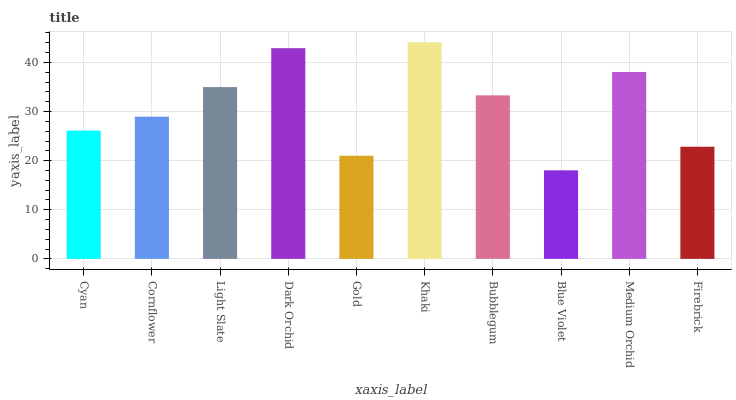Is Blue Violet the minimum?
Answer yes or no. Yes. Is Khaki the maximum?
Answer yes or no. Yes. Is Cornflower the minimum?
Answer yes or no. No. Is Cornflower the maximum?
Answer yes or no. No. Is Cornflower greater than Cyan?
Answer yes or no. Yes. Is Cyan less than Cornflower?
Answer yes or no. Yes. Is Cyan greater than Cornflower?
Answer yes or no. No. Is Cornflower less than Cyan?
Answer yes or no. No. Is Bubblegum the high median?
Answer yes or no. Yes. Is Cornflower the low median?
Answer yes or no. Yes. Is Gold the high median?
Answer yes or no. No. Is Light Slate the low median?
Answer yes or no. No. 